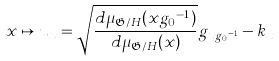Convert formula to latex. <formula><loc_0><loc_0><loc_500><loc_500>x \mapsto u _ { x } = \sqrt { \frac { d \mu _ { \mathfrak { G } / H } ( x { g _ { 0 } } ^ { - 1 } ) } { d \mu _ { \mathfrak { G } / H } ( x ) } } g _ { x { g _ { 0 } } ^ { - 1 } } - k _ { x }</formula> 